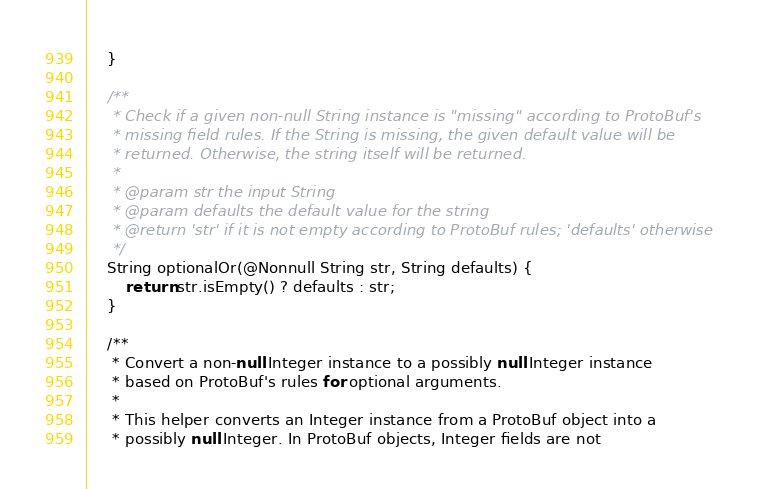Convert code to text. <code><loc_0><loc_0><loc_500><loc_500><_Java_>    }

    /**
     * Check if a given non-null String instance is "missing" according to ProtoBuf's
     * missing field rules. If the String is missing, the given default value will be
     * returned. Otherwise, the string itself will be returned.
     *
     * @param str the input String
     * @param defaults the default value for the string
     * @return 'str' if it is not empty according to ProtoBuf rules; 'defaults' otherwise
     */
    String optionalOr(@Nonnull String str, String defaults) {
        return str.isEmpty() ? defaults : str;
    }

    /**
     * Convert a non-null Integer instance to a possibly null Integer instance
     * based on ProtoBuf's rules for optional arguments.
     *
     * This helper converts an Integer instance from a ProtoBuf object into a
     * possibly null Integer. In ProtoBuf objects, Integer fields are not</code> 